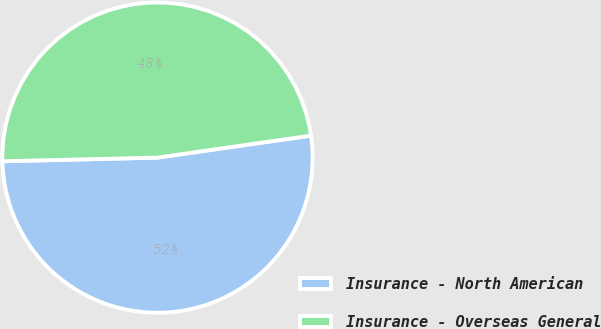Convert chart. <chart><loc_0><loc_0><loc_500><loc_500><pie_chart><fcel>Insurance - North American<fcel>Insurance - Overseas General<nl><fcel>51.89%<fcel>48.11%<nl></chart> 